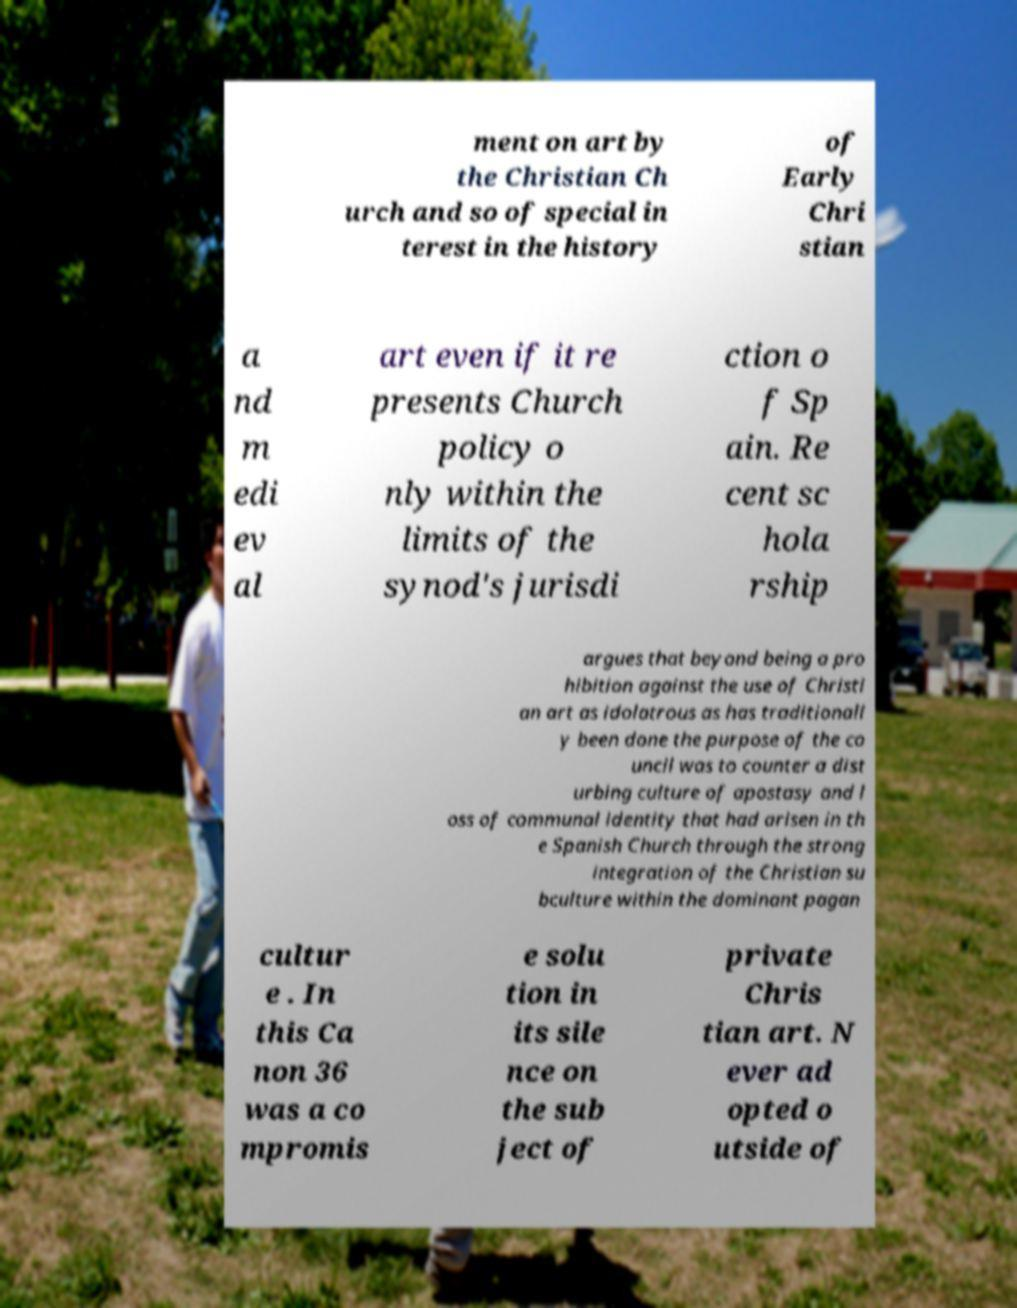Could you assist in decoding the text presented in this image and type it out clearly? ment on art by the Christian Ch urch and so of special in terest in the history of Early Chri stian a nd m edi ev al art even if it re presents Church policy o nly within the limits of the synod's jurisdi ction o f Sp ain. Re cent sc hola rship argues that beyond being a pro hibition against the use of Christi an art as idolatrous as has traditionall y been done the purpose of the co uncil was to counter a dist urbing culture of apostasy and l oss of communal identity that had arisen in th e Spanish Church through the strong integration of the Christian su bculture within the dominant pagan cultur e . In this Ca non 36 was a co mpromis e solu tion in its sile nce on the sub ject of private Chris tian art. N ever ad opted o utside of 